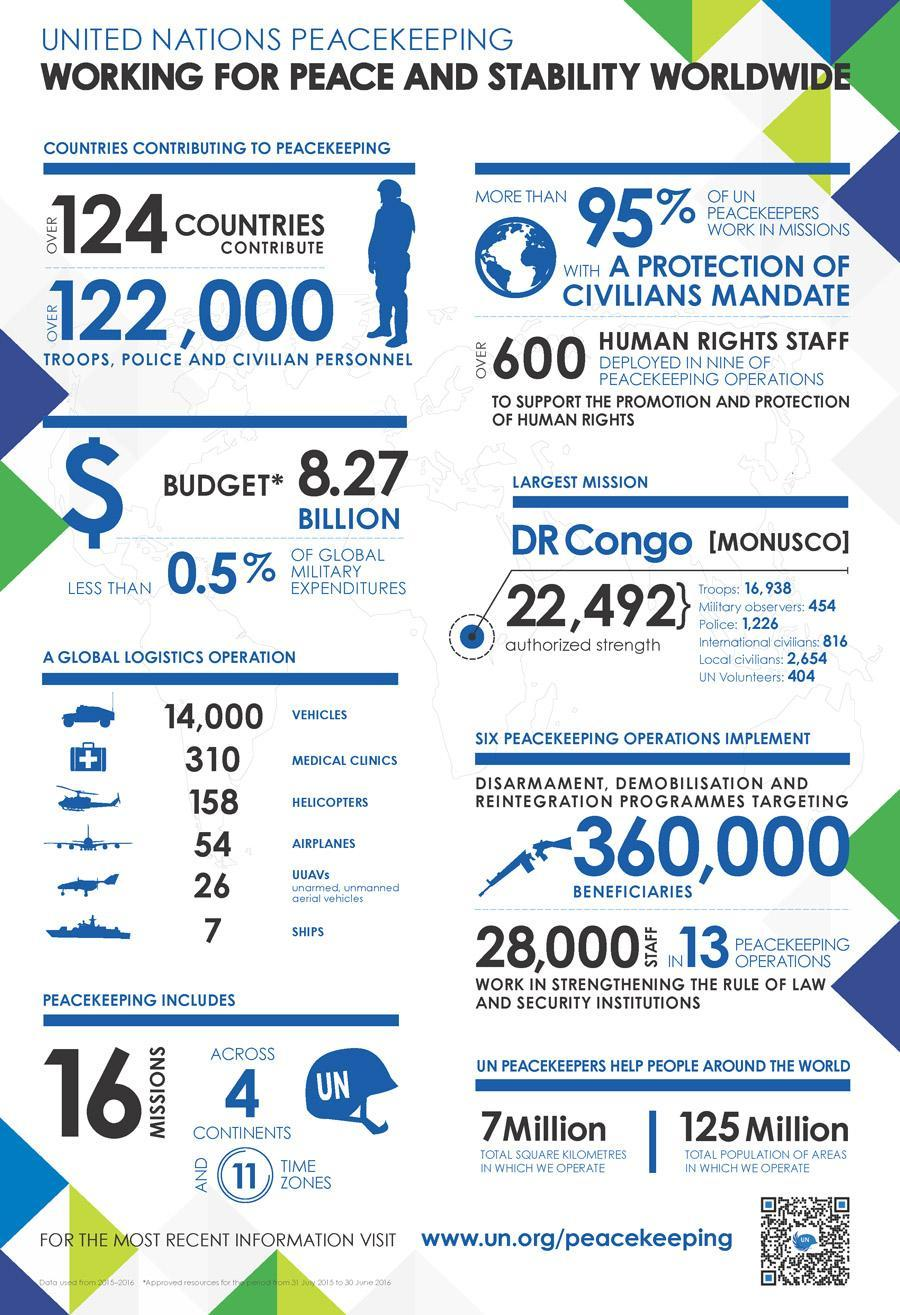How many continents are excluded from peacekeeping?
Answer the question with a short phrase. 3 What is the total number of vehicles used in logistics operations of the UN peacekeeping force? 14,555 How many countries do not contribute to peace keeping ? 71 countries 